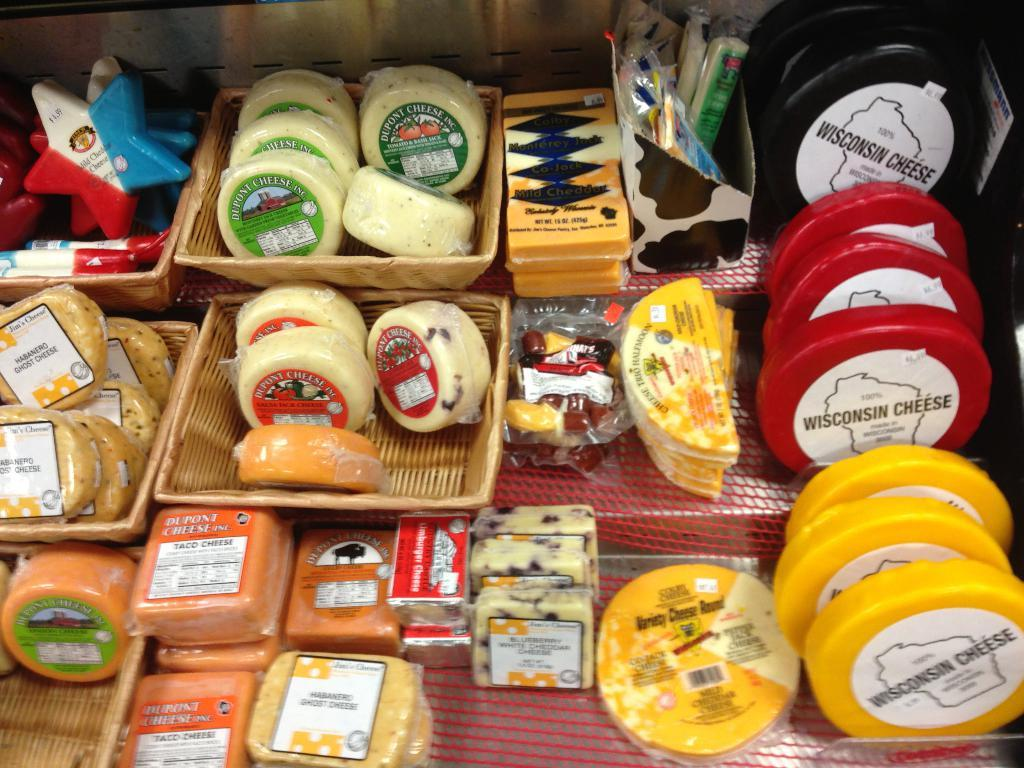<image>
Create a compact narrative representing the image presented. A large variety of cheese products including Wisconsin cheese and mild cheddar. 